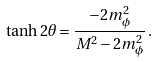<formula> <loc_0><loc_0><loc_500><loc_500>\tanh 2 \theta = \frac { - 2 m _ { \phi } ^ { 2 } } { M ^ { 2 } - 2 m _ { \phi } ^ { 2 } } \, .</formula> 